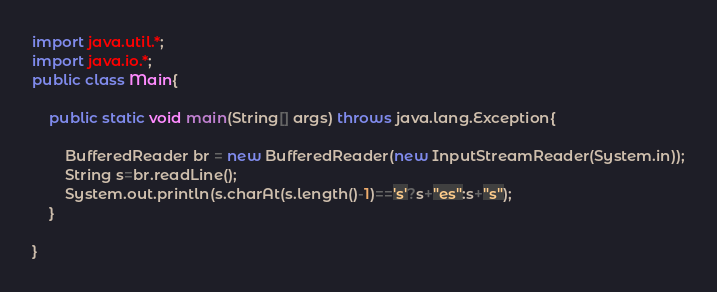Convert code to text. <code><loc_0><loc_0><loc_500><loc_500><_Java_>import java.util.*;
import java.io.*;
public class Main{

	public static void main(String[] args) throws java.lang.Exception{
		
		BufferedReader br = new BufferedReader(new InputStreamReader(System.in));
		String s=br.readLine();
		System.out.println(s.charAt(s.length()-1)=='s'?s+"es":s+"s");
	}

}
</code> 